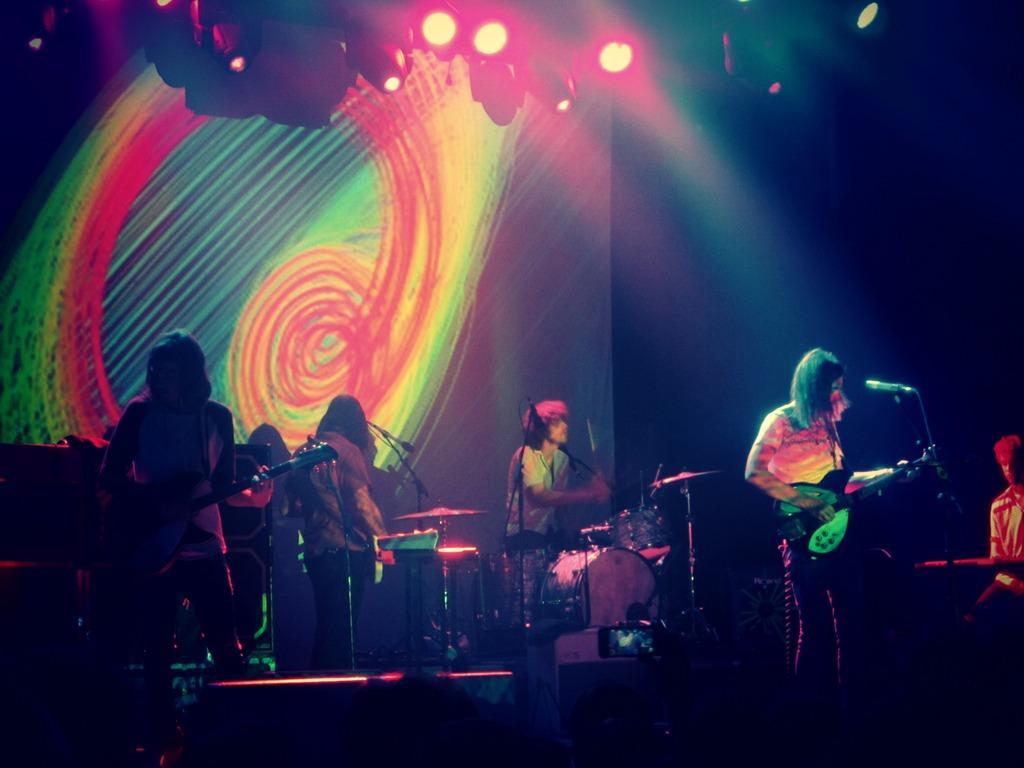Please provide a concise description of this image. It is looking like a concert is going on. There are few musicians playing musical instruments. There are mics in front of them. In the background there is screen. On the top there are lights. 